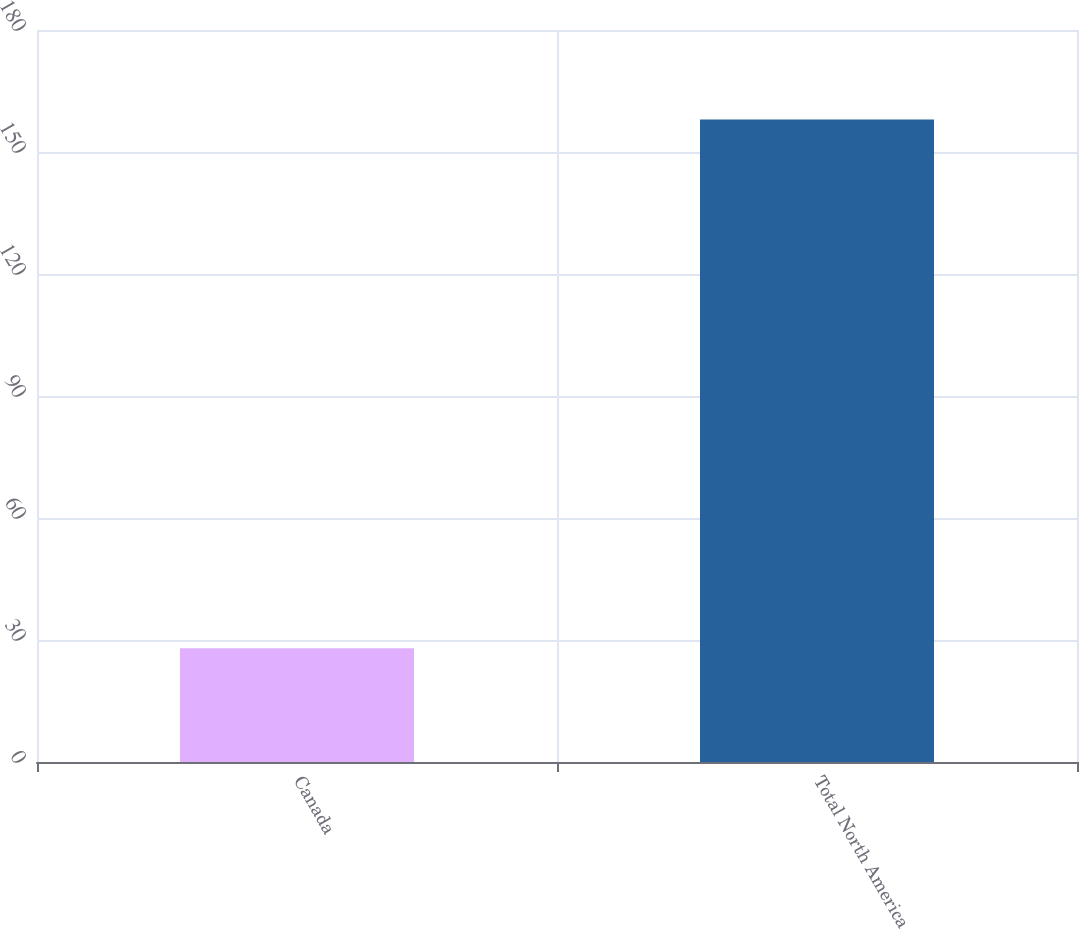<chart> <loc_0><loc_0><loc_500><loc_500><bar_chart><fcel>Canada<fcel>Total North America<nl><fcel>28<fcel>158<nl></chart> 